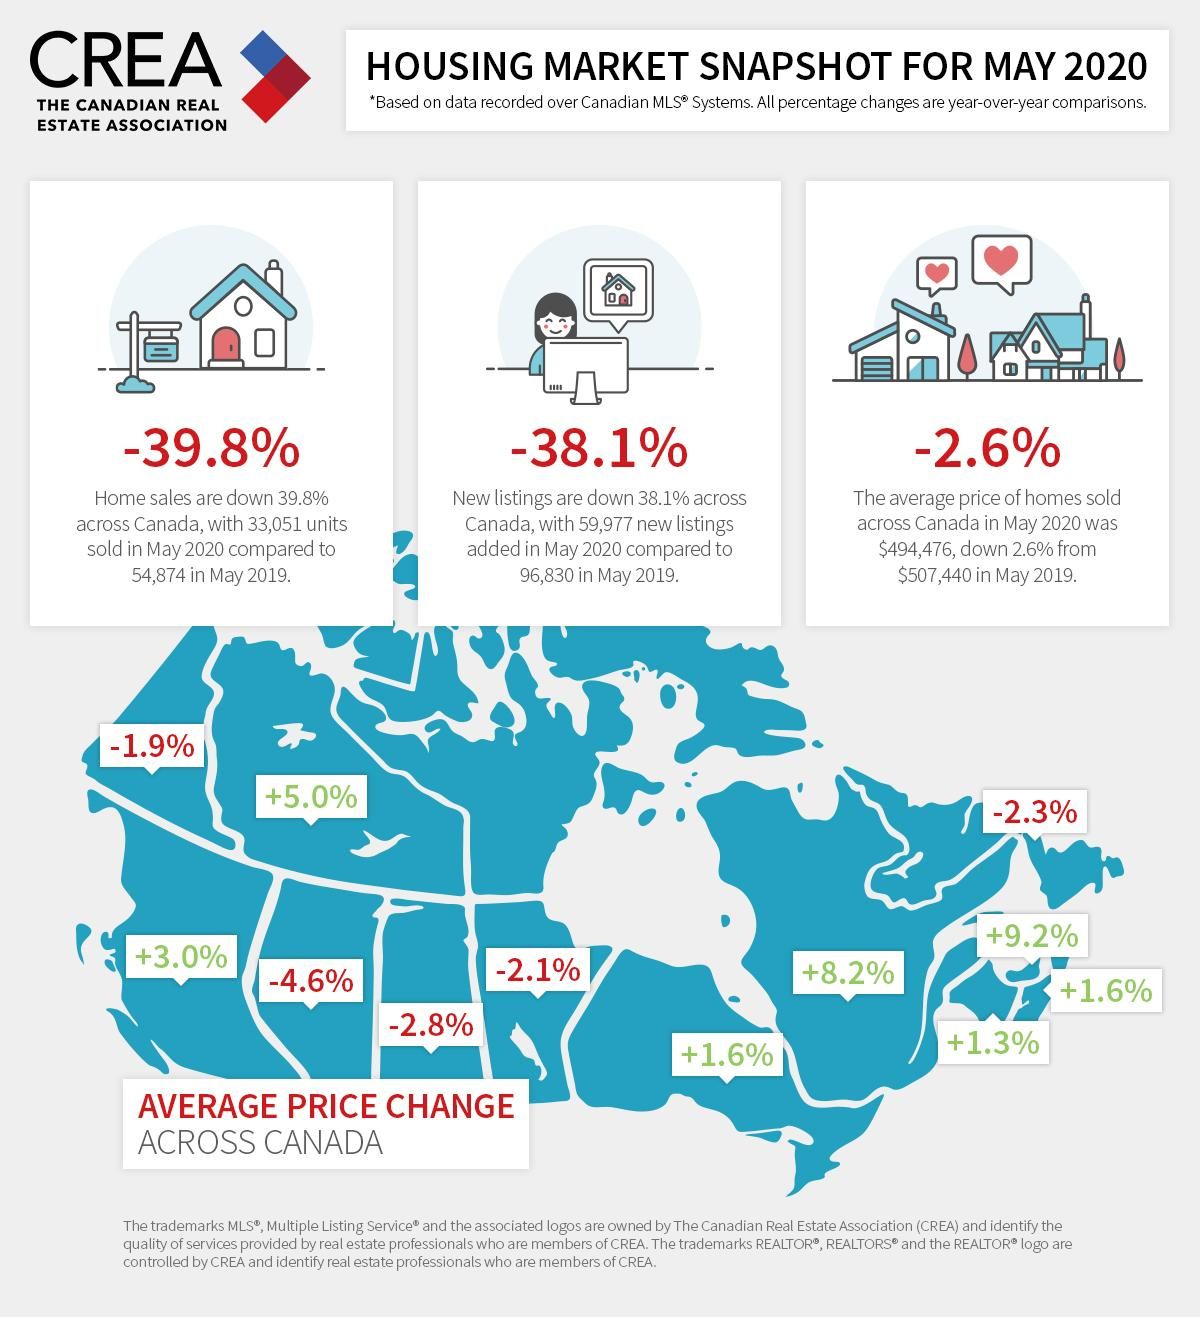Highlight a few significant elements in this photo. The lowest average price change increase observed was +1.3%. Out of all the regions in Canada, 7 show an increase in the average price change. The average price of homes sold across Canada in May 2020 was less than in May 2019 by 12,964. The highest increase in average price change observed was +9.2%. In 2020, the number of new listings was significantly lower than in 2019, amounting to a decrease of 3,6853. 